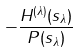Convert formula to latex. <formula><loc_0><loc_0><loc_500><loc_500>- \frac { H ^ { ( \lambda ) } ( s _ { \lambda } ) } { P ( s _ { \lambda } ) }</formula> 